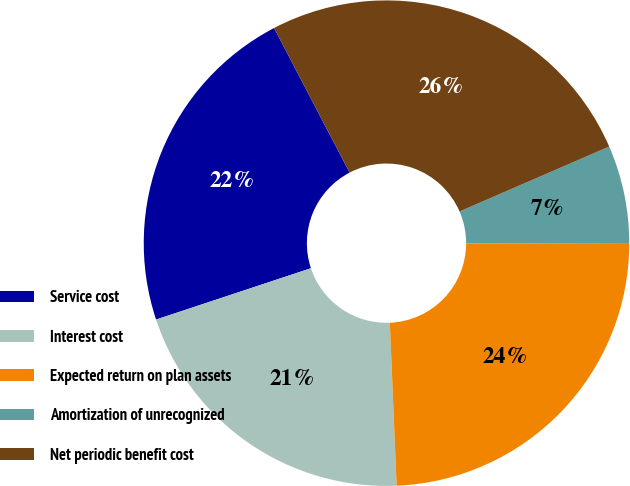Convert chart. <chart><loc_0><loc_0><loc_500><loc_500><pie_chart><fcel>Service cost<fcel>Interest cost<fcel>Expected return on plan assets<fcel>Amortization of unrecognized<fcel>Net periodic benefit cost<nl><fcel>22.43%<fcel>20.57%<fcel>24.29%<fcel>6.56%<fcel>26.15%<nl></chart> 